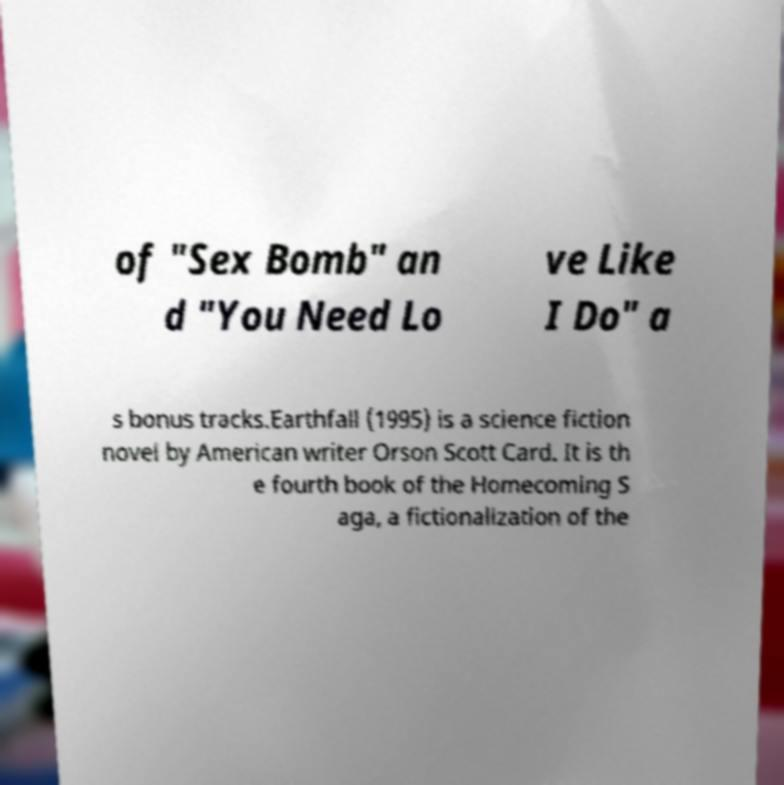What messages or text are displayed in this image? I need them in a readable, typed format. of "Sex Bomb" an d "You Need Lo ve Like I Do" a s bonus tracks.Earthfall (1995) is a science fiction novel by American writer Orson Scott Card. It is th e fourth book of the Homecoming S aga, a fictionalization of the 